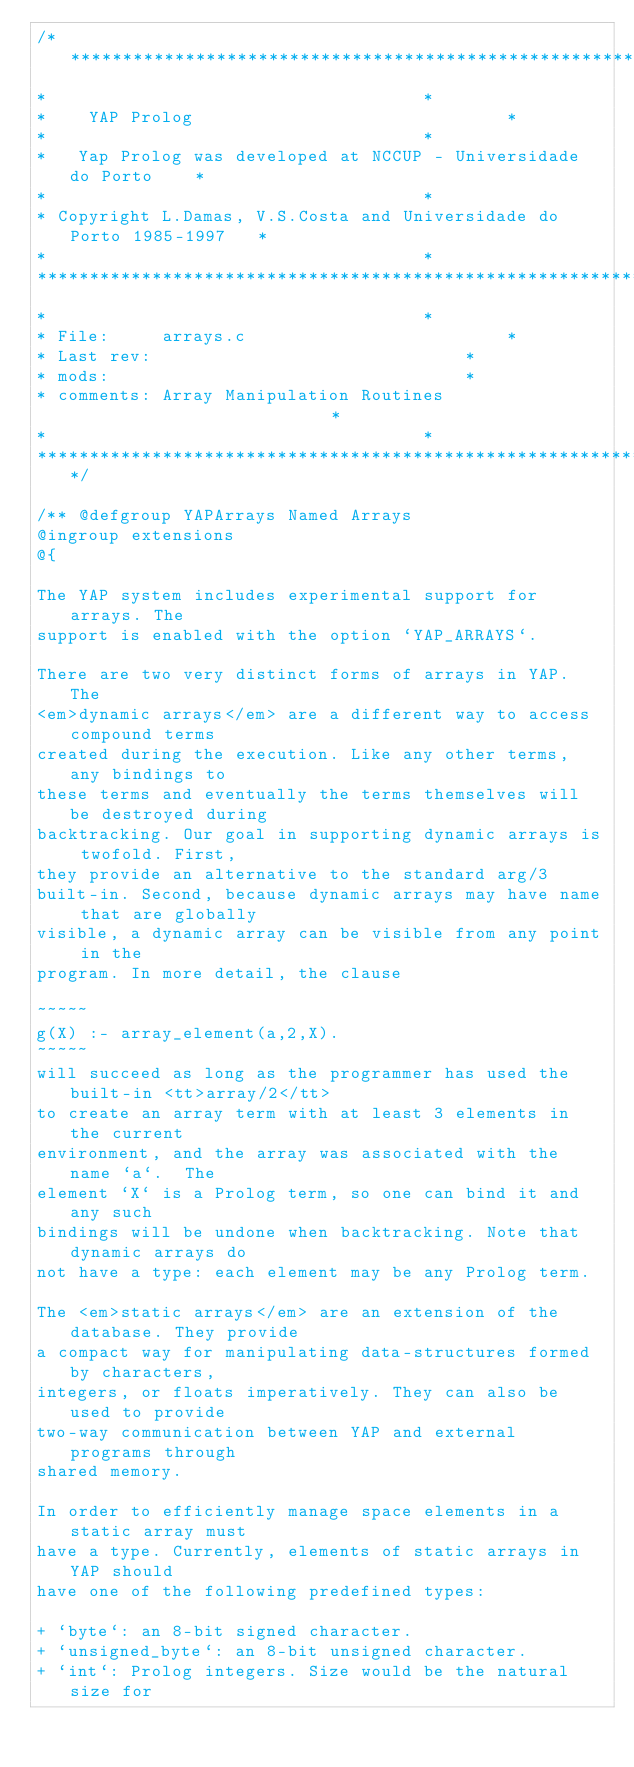Convert code to text. <code><loc_0><loc_0><loc_500><loc_500><_C_>/*************************************************************************
*									 *
*	 YAP Prolog 							 *
*									 *
*	Yap Prolog was developed at NCCUP - Universidade do Porto	 *
*									 *
* Copyright L.Damas, V.S.Costa and Universidade do Porto 1985-1997	 *
*									 *
**************************************************************************
*									 *
* File:		arrays.c						 *
* Last rev:								 *
* mods:									 *
* comments:	Array Manipulation Routines	                         *
*									 *
*************************************************************************/

/** @defgroup YAPArrays Named Arrays
@ingroup extensions
@{

The YAP system includes experimental support for arrays. The
support is enabled with the option `YAP_ARRAYS`.

There are two very distinct forms of arrays in YAP. The
<em>dynamic arrays</em> are a different way to access compound terms
created during the execution. Like any other terms, any bindings to
these terms and eventually the terms themselves will be destroyed during
backtracking. Our goal in supporting dynamic arrays is twofold. First,
they provide an alternative to the standard arg/3
built-in. Second, because dynamic arrays may have name that are globally
visible, a dynamic array can be visible from any point in the
program. In more detail, the clause

~~~~~
g(X) :- array_element(a,2,X).
~~~~~
will succeed as long as the programmer has used the built-in <tt>array/2</tt>
to create an array term with at least 3 elements in the current
environment, and the array was associated with the name `a`.  The
element `X` is a Prolog term, so one can bind it and any such
bindings will be undone when backtracking. Note that dynamic arrays do
not have a type: each element may be any Prolog term.

The <em>static arrays</em> are an extension of the database. They provide
a compact way for manipulating data-structures formed by characters,
integers, or floats imperatively. They can also be used to provide
two-way communication between YAP and external programs through
shared memory.

In order to efficiently manage space elements in a static array must
have a type. Currently, elements of static arrays in YAP should
have one of the following predefined types:

+ `byte`: an 8-bit signed character.
+ `unsigned_byte`: an 8-bit unsigned character.
+ `int`: Prolog integers. Size would be the natural size for</code> 